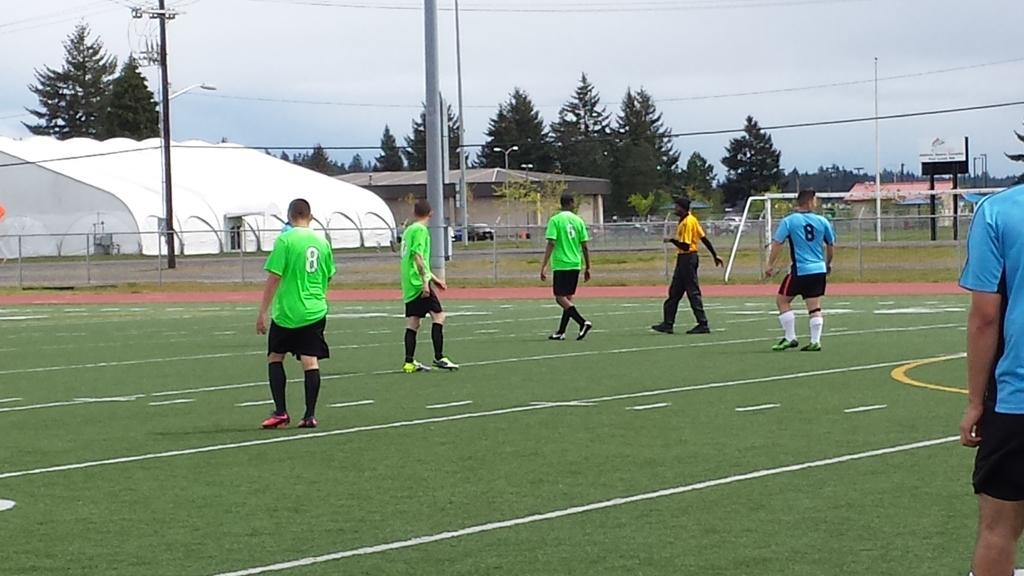What number is on the green shirt?
Offer a very short reply. 8. 